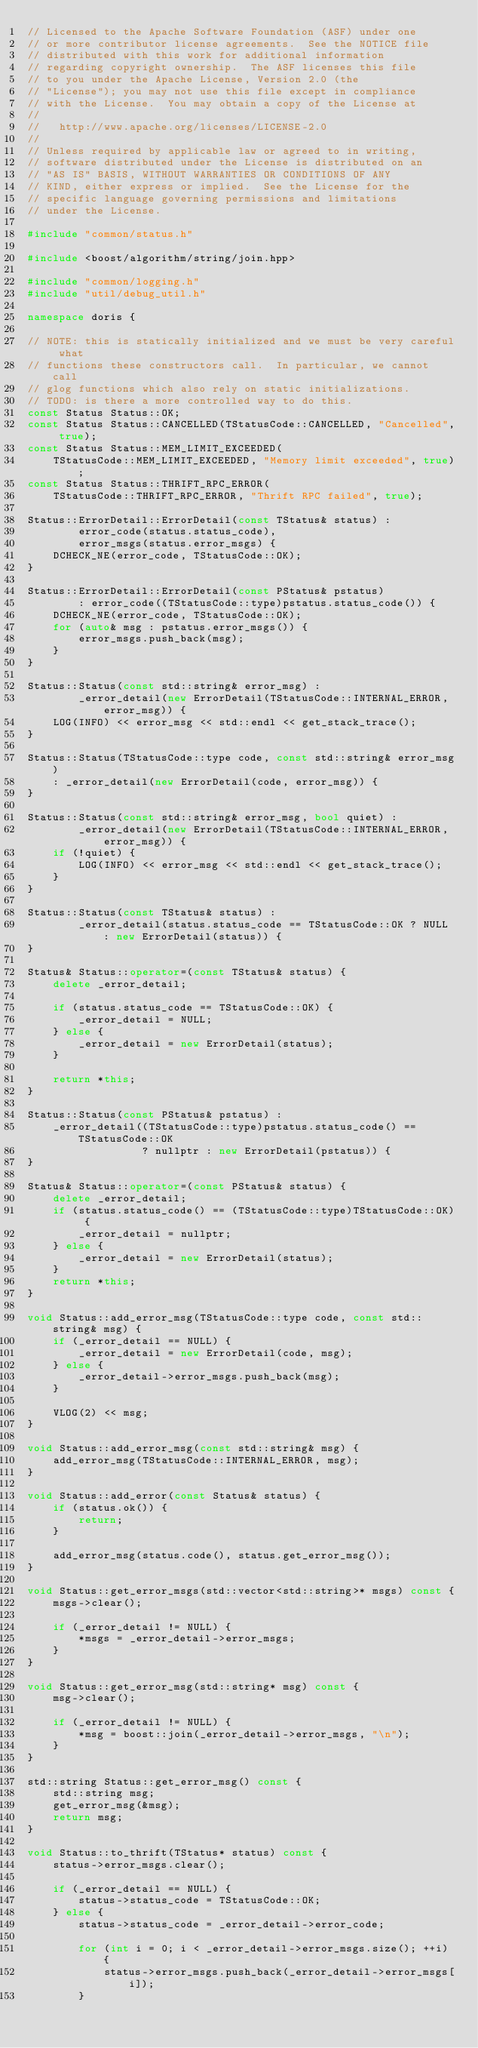<code> <loc_0><loc_0><loc_500><loc_500><_C++_>// Licensed to the Apache Software Foundation (ASF) under one
// or more contributor license agreements.  See the NOTICE file
// distributed with this work for additional information
// regarding copyright ownership.  The ASF licenses this file
// to you under the Apache License, Version 2.0 (the
// "License"); you may not use this file except in compliance
// with the License.  You may obtain a copy of the License at
//
//   http://www.apache.org/licenses/LICENSE-2.0
//
// Unless required by applicable law or agreed to in writing,
// software distributed under the License is distributed on an
// "AS IS" BASIS, WITHOUT WARRANTIES OR CONDITIONS OF ANY
// KIND, either express or implied.  See the License for the
// specific language governing permissions and limitations
// under the License.

#include "common/status.h"

#include <boost/algorithm/string/join.hpp>

#include "common/logging.h"
#include "util/debug_util.h"

namespace doris {

// NOTE: this is statically initialized and we must be very careful what
// functions these constructors call.  In particular, we cannot call
// glog functions which also rely on static initializations.
// TODO: is there a more controlled way to do this.
const Status Status::OK;
const Status Status::CANCELLED(TStatusCode::CANCELLED, "Cancelled", true);
const Status Status::MEM_LIMIT_EXCEEDED(
    TStatusCode::MEM_LIMIT_EXCEEDED, "Memory limit exceeded", true);
const Status Status::THRIFT_RPC_ERROR(
    TStatusCode::THRIFT_RPC_ERROR, "Thrift RPC failed", true);

Status::ErrorDetail::ErrorDetail(const TStatus& status) : 
        error_code(status.status_code),
        error_msgs(status.error_msgs) {
    DCHECK_NE(error_code, TStatusCode::OK);
}

Status::ErrorDetail::ErrorDetail(const PStatus& pstatus)
        : error_code((TStatusCode::type)pstatus.status_code()) {
    DCHECK_NE(error_code, TStatusCode::OK);
    for (auto& msg : pstatus.error_msgs()) {
        error_msgs.push_back(msg);
    }
}

Status::Status(const std::string& error_msg) : 
        _error_detail(new ErrorDetail(TStatusCode::INTERNAL_ERROR, error_msg)) {
    LOG(INFO) << error_msg << std::endl << get_stack_trace();
}

Status::Status(TStatusCode::type code, const std::string& error_msg)
    : _error_detail(new ErrorDetail(code, error_msg)) {
}

Status::Status(const std::string& error_msg, bool quiet) : 
        _error_detail(new ErrorDetail(TStatusCode::INTERNAL_ERROR, error_msg)) {
    if (!quiet) {
        LOG(INFO) << error_msg << std::endl << get_stack_trace();
    }
}

Status::Status(const TStatus& status) : 
        _error_detail(status.status_code == TStatusCode::OK ? NULL : new ErrorDetail(status)) {
}

Status& Status::operator=(const TStatus& status) {
    delete _error_detail;

    if (status.status_code == TStatusCode::OK) {
        _error_detail = NULL;
    } else {
        _error_detail = new ErrorDetail(status);
    }

    return *this;
}

Status::Status(const PStatus& pstatus) :
    _error_detail((TStatusCode::type)pstatus.status_code() == TStatusCode::OK
                  ? nullptr : new ErrorDetail(pstatus)) {
}

Status& Status::operator=(const PStatus& status) {
    delete _error_detail;
    if (status.status_code() == (TStatusCode::type)TStatusCode::OK) {
        _error_detail = nullptr;
    } else {
        _error_detail = new ErrorDetail(status);
    }
    return *this;
}

void Status::add_error_msg(TStatusCode::type code, const std::string& msg) {
    if (_error_detail == NULL) {
        _error_detail = new ErrorDetail(code, msg);
    } else {
        _error_detail->error_msgs.push_back(msg);
    }

    VLOG(2) << msg;
}

void Status::add_error_msg(const std::string& msg) {
    add_error_msg(TStatusCode::INTERNAL_ERROR, msg);
}

void Status::add_error(const Status& status) {
    if (status.ok()) {
        return;
    }

    add_error_msg(status.code(), status.get_error_msg());
}

void Status::get_error_msgs(std::vector<std::string>* msgs) const {
    msgs->clear();

    if (_error_detail != NULL) {
        *msgs = _error_detail->error_msgs;
    }
}

void Status::get_error_msg(std::string* msg) const {
    msg->clear();

    if (_error_detail != NULL) {
        *msg = boost::join(_error_detail->error_msgs, "\n");
    }
}

std::string Status::get_error_msg() const {
    std::string msg;
    get_error_msg(&msg);
    return msg;
}

void Status::to_thrift(TStatus* status) const {
    status->error_msgs.clear();

    if (_error_detail == NULL) {
        status->status_code = TStatusCode::OK;
    } else {
        status->status_code = _error_detail->error_code;

        for (int i = 0; i < _error_detail->error_msgs.size(); ++i) {
            status->error_msgs.push_back(_error_detail->error_msgs[i]);
        }
</code> 